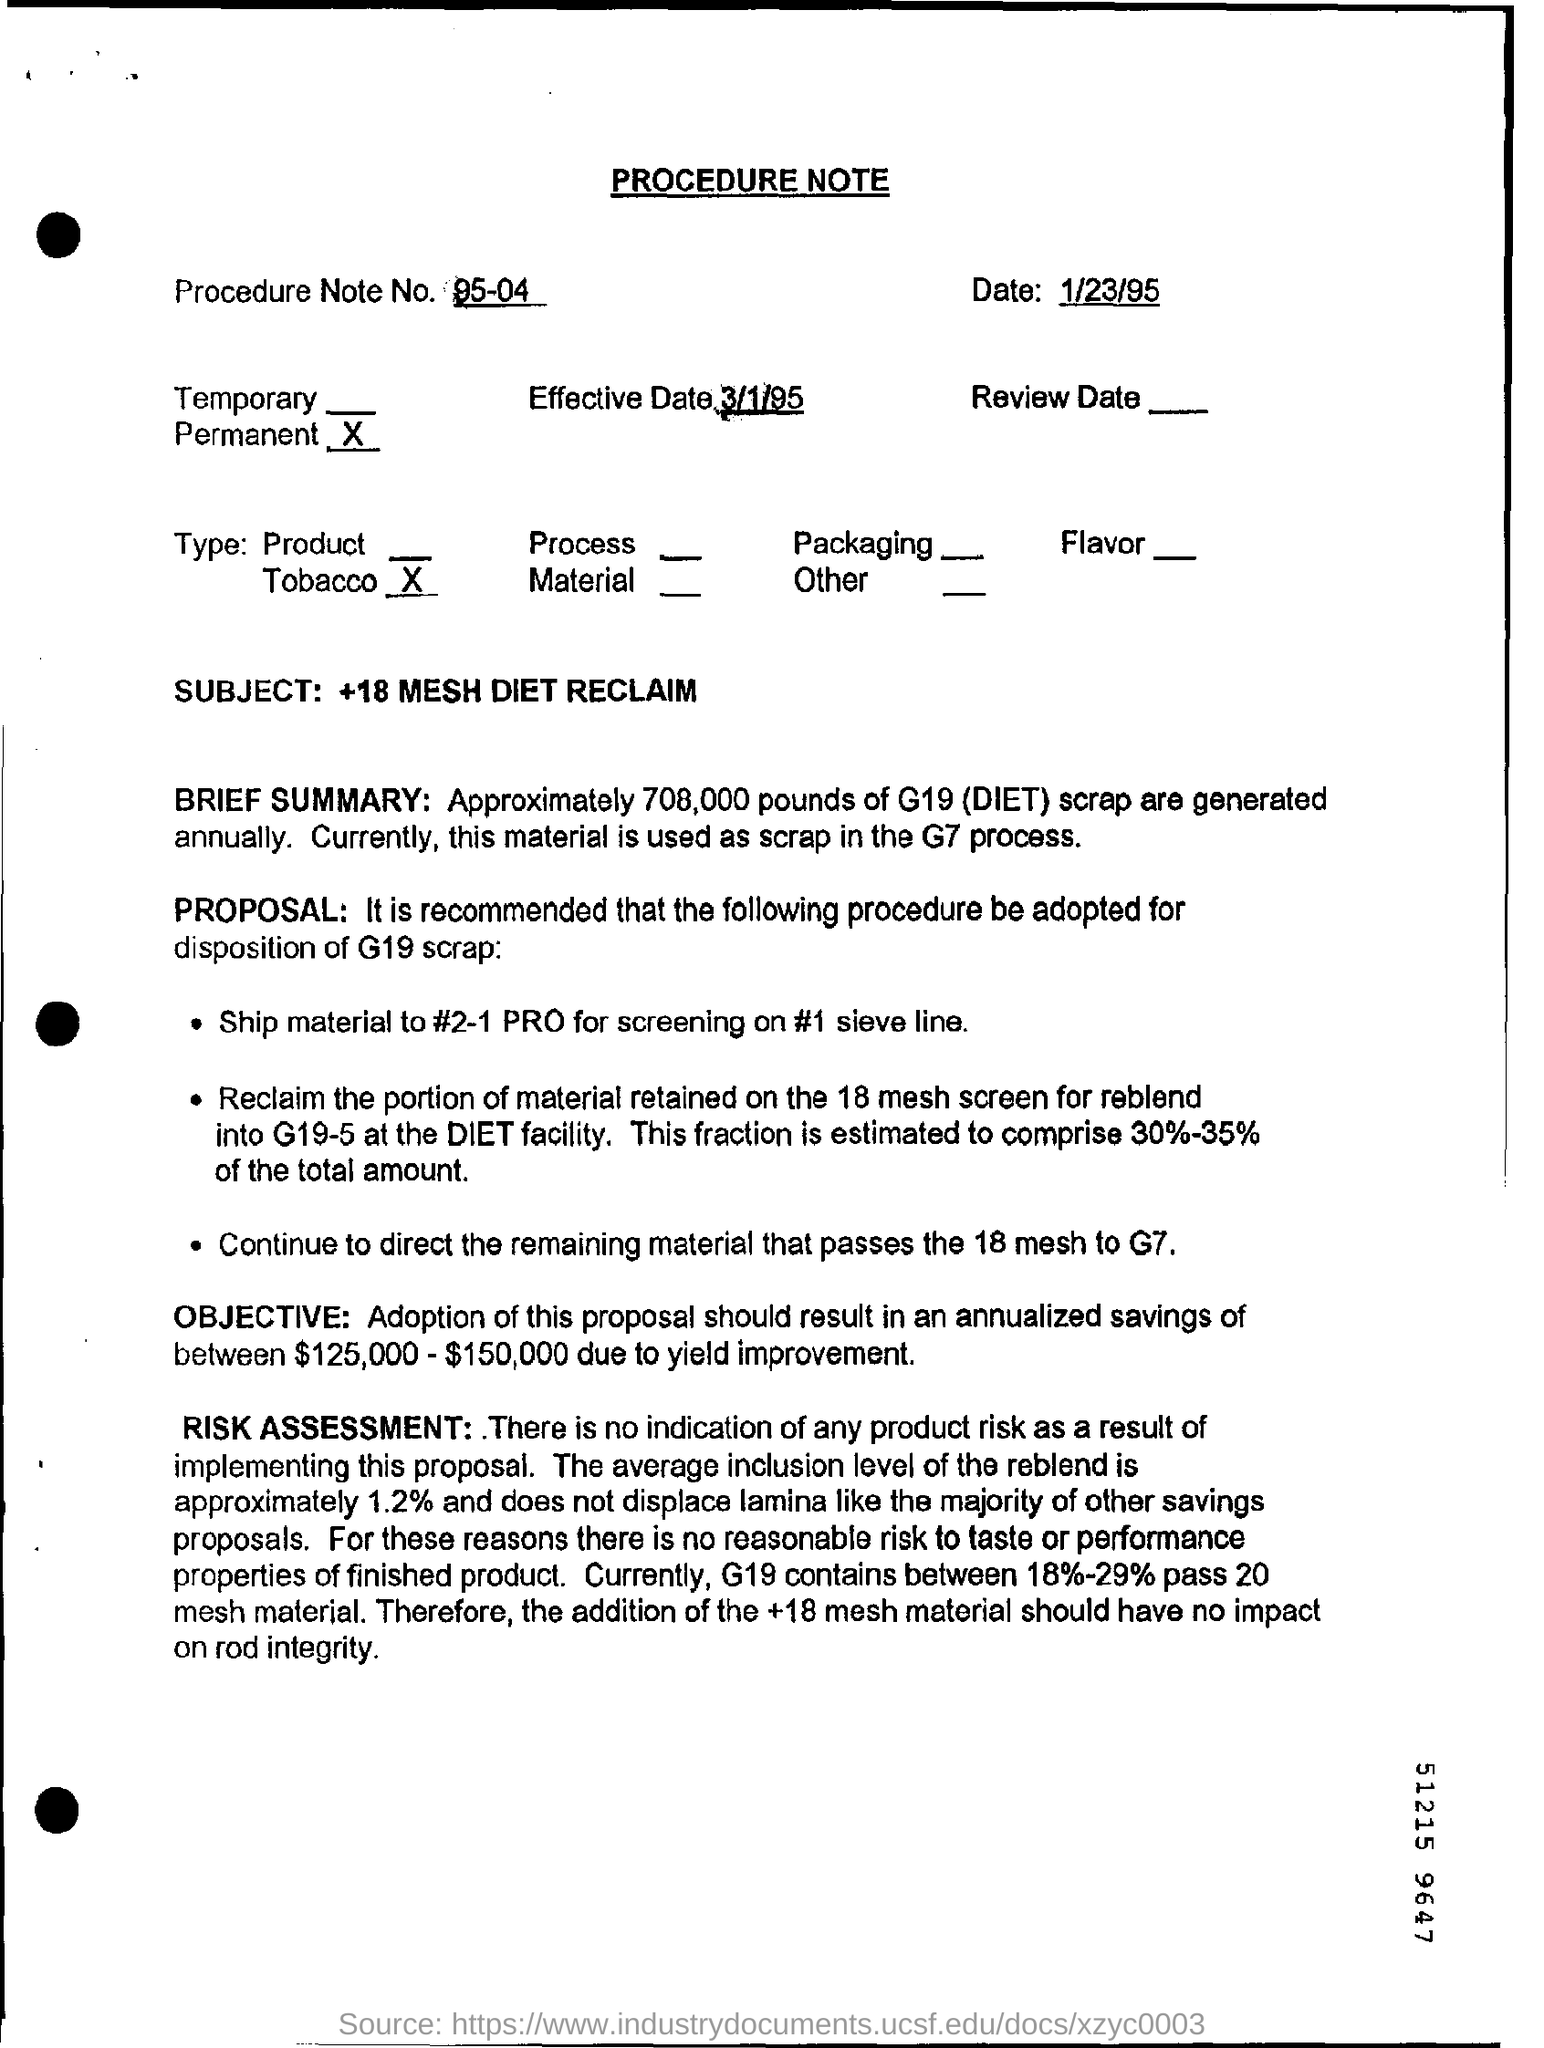Give some essential details in this illustration. This is a Procedure Note. The subject mentioned in the procedure note is "18 mesh diet reclaim. The effective date mentioned in this document is March 1, 1995. The annual generation of G19(DIET) scrap is approximately 708,000 pounds. The procedure note number of the given document is 95-04. 